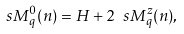Convert formula to latex. <formula><loc_0><loc_0><loc_500><loc_500>\ s M _ { q } ^ { 0 } ( n ) = H + 2 \ s M _ { q } ^ { z } ( n ) ,</formula> 